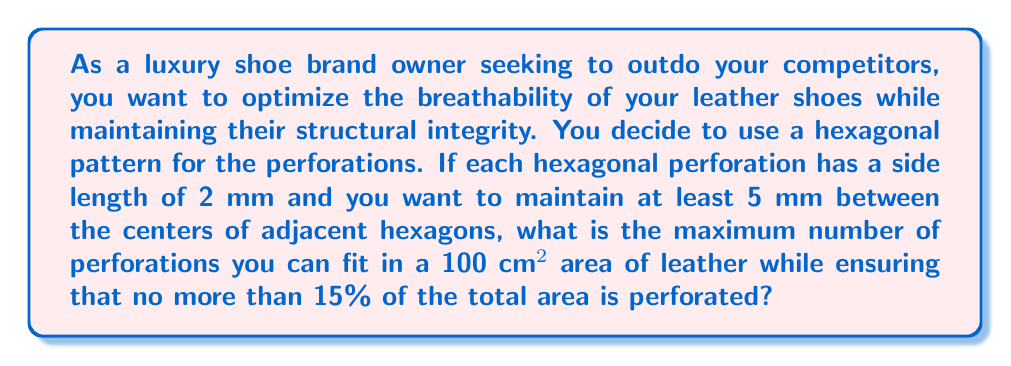What is the answer to this math problem? Let's approach this problem step by step:

1. Calculate the area of each hexagonal perforation:
   The area of a regular hexagon is given by $A = \frac{3\sqrt{3}}{2}s^2$, where $s$ is the side length.
   $$A_{hex} = \frac{3\sqrt{3}}{2}(2\text{ mm})^2 = 6\sqrt{3}\text{ mm}^2$$

2. Calculate the minimum center-to-center distance between hexagons:
   The diameter of the circumscribed circle of a hexagon is $2s = 4\text{ mm}$.
   The minimum center-to-center distance is $5\text{ mm}$, so we'll use this for our calculations.

3. Calculate the area occupied by each hexagon and its surrounding space:
   We can approximate this as a circle with diameter 5 mm.
   $$A_{circle} = \pi r^2 = \pi(\frac{5}{2})^2 = \frac{25\pi}{4}\text{ mm}^2$$

4. Calculate the number of perforations that can fit in 100 cm²:
   $$N = \frac{100\text{ cm}^2}{\frac{25\pi}{4}\text{ mm}^2} \times 100 = \frac{16000}{\pi} \approx 5092.96$$
   Rounding down, we get 5092 perforations.

5. Check if this satisfies the 15% area constraint:
   Total perforated area: $5092 \times 6\sqrt{3}\text{ mm}^2 = 30552\sqrt{3}\text{ mm}^2 \approx 52935.81\text{ mm}^2$
   Percentage of total area: $\frac{52935.81}{1000000} \times 100\% \approx 5.29\%$

   This is well below the 15% limit, so we can use this number of perforations.
Answer: The maximum number of hexagonal perforations that can be fit in a 100 cm² area of leather while maintaining the given constraints is 5092. 